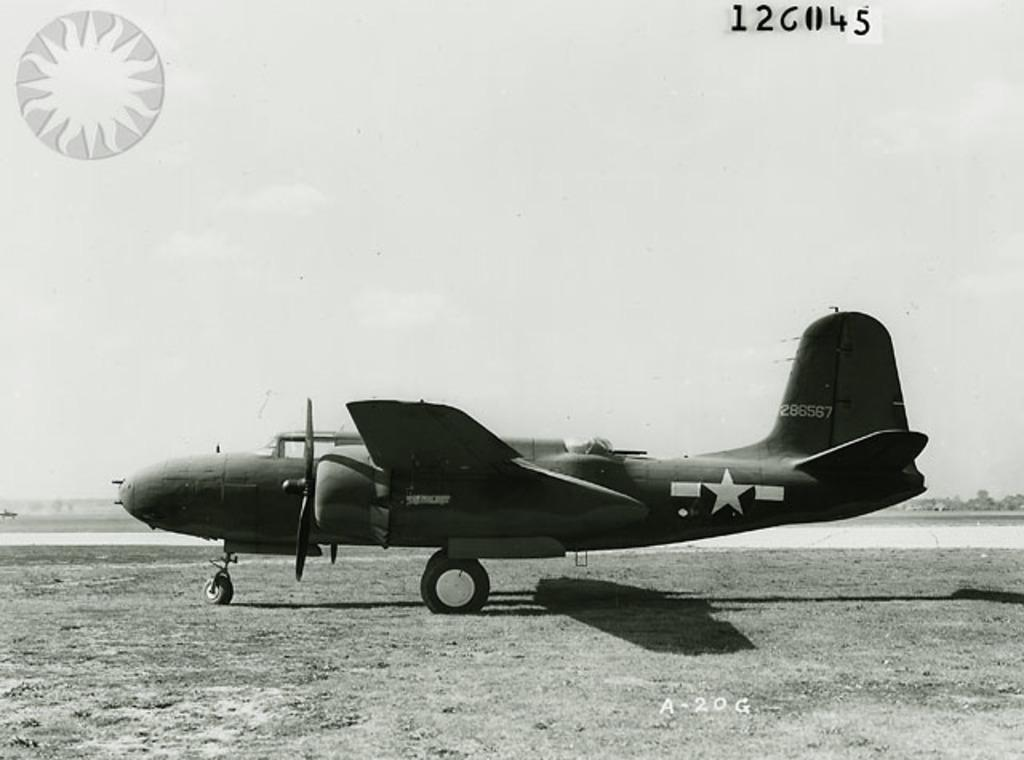<image>
Create a compact narrative representing the image presented. Airplane with numbers 286567 in white on the back of the airplane 